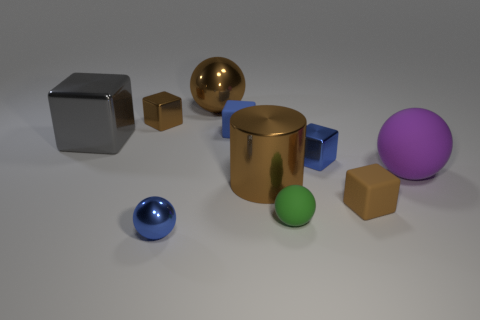Subtract all small rubber blocks. How many blocks are left? 3 Subtract all brown cubes. How many cubes are left? 3 Subtract 4 cubes. How many cubes are left? 1 Subtract all red cubes. Subtract all brown cylinders. How many cubes are left? 5 Add 4 purple balls. How many purple balls are left? 5 Add 7 purple spheres. How many purple spheres exist? 8 Subtract 0 purple cylinders. How many objects are left? 10 Subtract all spheres. How many objects are left? 6 Subtract all yellow spheres. How many gray cubes are left? 1 Subtract all green balls. Subtract all gray shiny things. How many objects are left? 8 